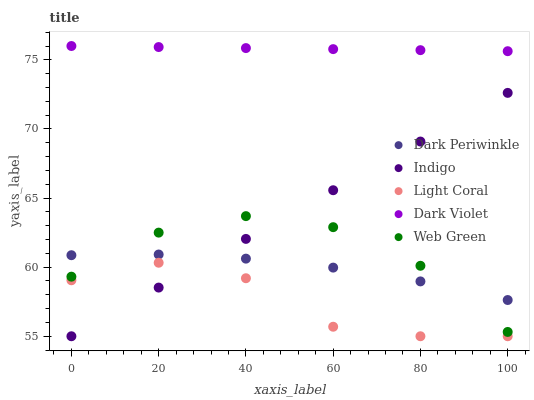Does Light Coral have the minimum area under the curve?
Answer yes or no. Yes. Does Dark Violet have the maximum area under the curve?
Answer yes or no. Yes. Does Web Green have the minimum area under the curve?
Answer yes or no. No. Does Web Green have the maximum area under the curve?
Answer yes or no. No. Is Indigo the smoothest?
Answer yes or no. Yes. Is Light Coral the roughest?
Answer yes or no. Yes. Is Web Green the smoothest?
Answer yes or no. No. Is Web Green the roughest?
Answer yes or no. No. Does Light Coral have the lowest value?
Answer yes or no. Yes. Does Web Green have the lowest value?
Answer yes or no. No. Does Dark Violet have the highest value?
Answer yes or no. Yes. Does Web Green have the highest value?
Answer yes or no. No. Is Light Coral less than Dark Periwinkle?
Answer yes or no. Yes. Is Dark Violet greater than Light Coral?
Answer yes or no. Yes. Does Web Green intersect Indigo?
Answer yes or no. Yes. Is Web Green less than Indigo?
Answer yes or no. No. Is Web Green greater than Indigo?
Answer yes or no. No. Does Light Coral intersect Dark Periwinkle?
Answer yes or no. No. 